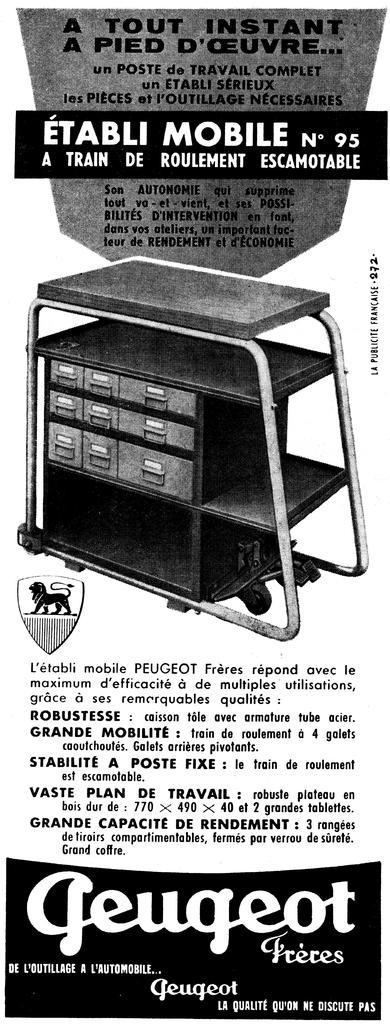<image>
Write a terse but informative summary of the picture. An old advertisement that is from Geugeot, an automobile company. 